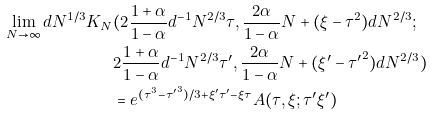<formula> <loc_0><loc_0><loc_500><loc_500>\lim _ { N \to \infty } d N ^ { 1 / 3 } K _ { N } & ( 2 \frac { 1 + \alpha } { 1 - \alpha } d ^ { - 1 } N ^ { 2 / 3 } \tau , \frac { 2 \alpha } { 1 - \alpha } N + ( \xi - \tau ^ { 2 } ) d N ^ { 2 / 3 } ; \\ & 2 \frac { 1 + \alpha } { 1 - \alpha } d ^ { - 1 } N ^ { 2 / 3 } \tau ^ { \prime } , \frac { 2 \alpha } { 1 - \alpha } N + ( \xi ^ { \prime } - { \tau ^ { \prime } } ^ { 2 } ) d N ^ { 2 / 3 } ) \\ & = e ^ { ( \tau ^ { 3 } - { \tau ^ { \prime } } ^ { 3 } ) / 3 + \xi ^ { \prime } \tau ^ { \prime } - \xi \tau } A ( \tau , \xi ; \tau ^ { \prime } \xi ^ { \prime } )</formula> 